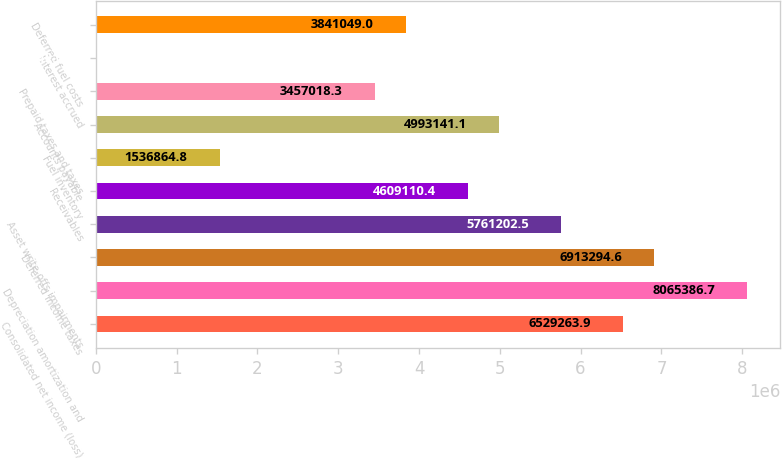Convert chart to OTSL. <chart><loc_0><loc_0><loc_500><loc_500><bar_chart><fcel>Consolidated net income (loss)<fcel>Depreciation amortization and<fcel>Deferred income taxes<fcel>Asset write-offs impairments<fcel>Receivables<fcel>Fuel inventory<fcel>Accounts payable<fcel>Prepaid taxes and taxes<fcel>Interest accrued<fcel>Deferred fuel costs<nl><fcel>6.52926e+06<fcel>8.06539e+06<fcel>6.91329e+06<fcel>5.7612e+06<fcel>4.60911e+06<fcel>1.53686e+06<fcel>4.99314e+06<fcel>3.45702e+06<fcel>742<fcel>3.84105e+06<nl></chart> 